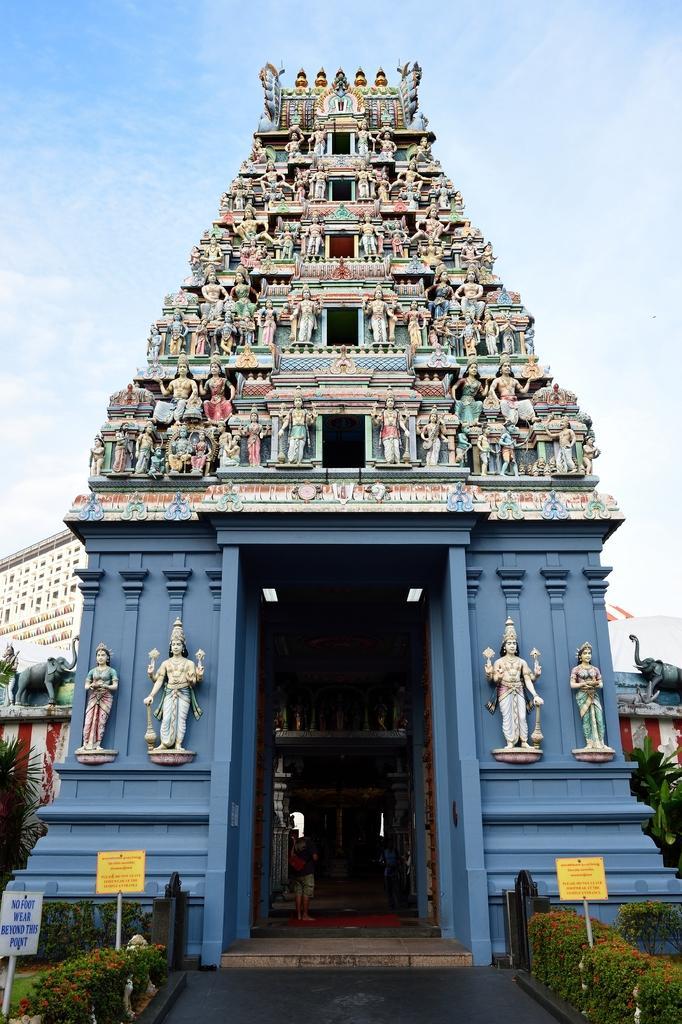Could you give a brief overview of what you see in this image? In this image there is a temple, people, idols, plants, boards, grass, cloudy sky and objects. 